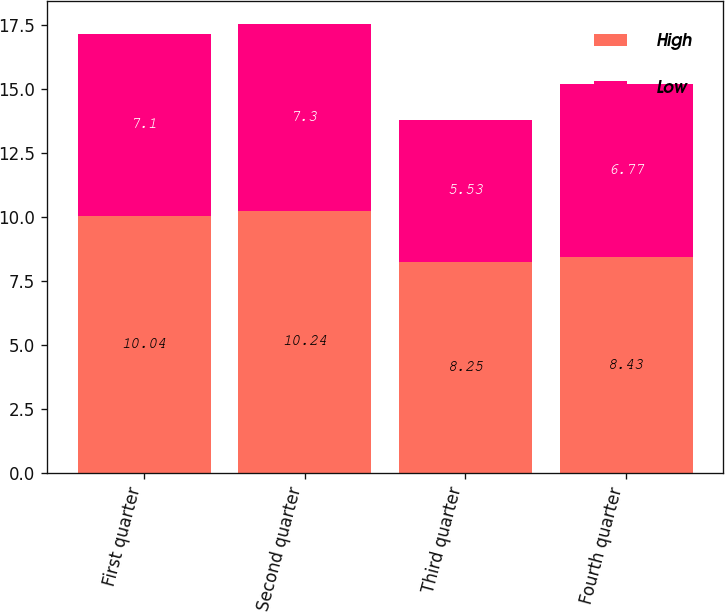Convert chart. <chart><loc_0><loc_0><loc_500><loc_500><stacked_bar_chart><ecel><fcel>First quarter<fcel>Second quarter<fcel>Third quarter<fcel>Fourth quarter<nl><fcel>High<fcel>10.04<fcel>10.24<fcel>8.25<fcel>8.43<nl><fcel>Low<fcel>7.1<fcel>7.3<fcel>5.53<fcel>6.77<nl></chart> 